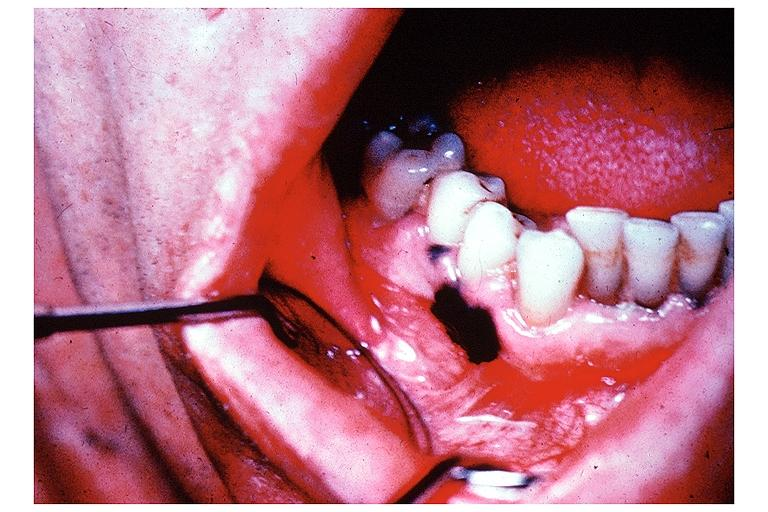s oral present?
Answer the question using a single word or phrase. Yes 